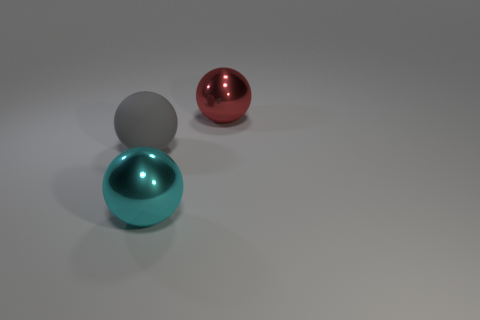Subtract all metallic balls. How many balls are left? 1 Subtract all cyan balls. How many balls are left? 2 Subtract 1 balls. How many balls are left? 2 Add 2 red shiny objects. How many red shiny objects exist? 3 Add 2 green blocks. How many objects exist? 5 Subtract 1 cyan spheres. How many objects are left? 2 Subtract all gray spheres. Subtract all green cylinders. How many spheres are left? 2 Subtract all blue cylinders. How many purple spheres are left? 0 Subtract all big matte spheres. Subtract all red shiny spheres. How many objects are left? 1 Add 3 gray balls. How many gray balls are left? 4 